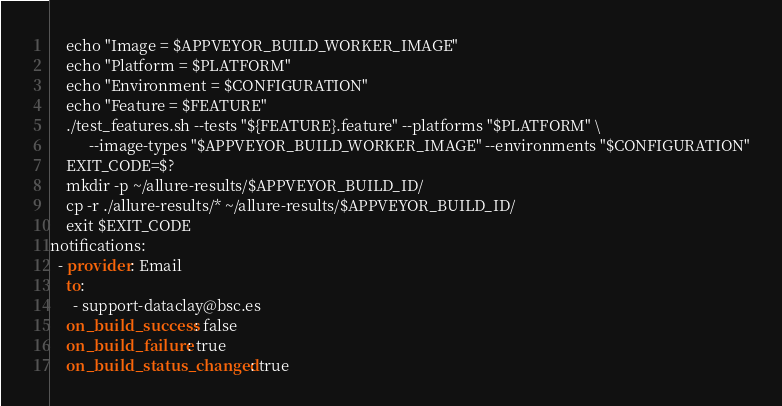<code> <loc_0><loc_0><loc_500><loc_500><_YAML_>    echo "Image = $APPVEYOR_BUILD_WORKER_IMAGE"
    echo "Platform = $PLATFORM"
    echo "Environment = $CONFIGURATION"
    echo "Feature = $FEATURE"
    ./test_features.sh --tests "${FEATURE}.feature" --platforms "$PLATFORM" \
          --image-types "$APPVEYOR_BUILD_WORKER_IMAGE" --environments "$CONFIGURATION"
    EXIT_CODE=$?
    mkdir -p ~/allure-results/$APPVEYOR_BUILD_ID/
    cp -r ./allure-results/* ~/allure-results/$APPVEYOR_BUILD_ID/
    exit $EXIT_CODE
notifications:
  - provider: Email
    to:
      - support-dataclay@bsc.es
    on_build_success: false
    on_build_failure: true
    on_build_status_changed: true</code> 